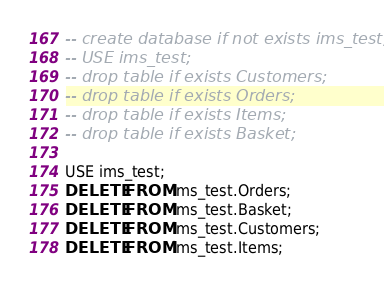Convert code to text. <code><loc_0><loc_0><loc_500><loc_500><_SQL_>-- create database if not exists ims_test;
-- USE ims_test;
-- drop table if exists Customers;
-- drop table if exists Orders;
-- drop table if exists Items;
-- drop table if exists Basket;

USE ims_test;
DELETE FROM ims_test.Orders;
DELETE FROM ims_test.Basket;
DELETE FROM ims_test.Customers;
DELETE FROM ims_test.Items;</code> 